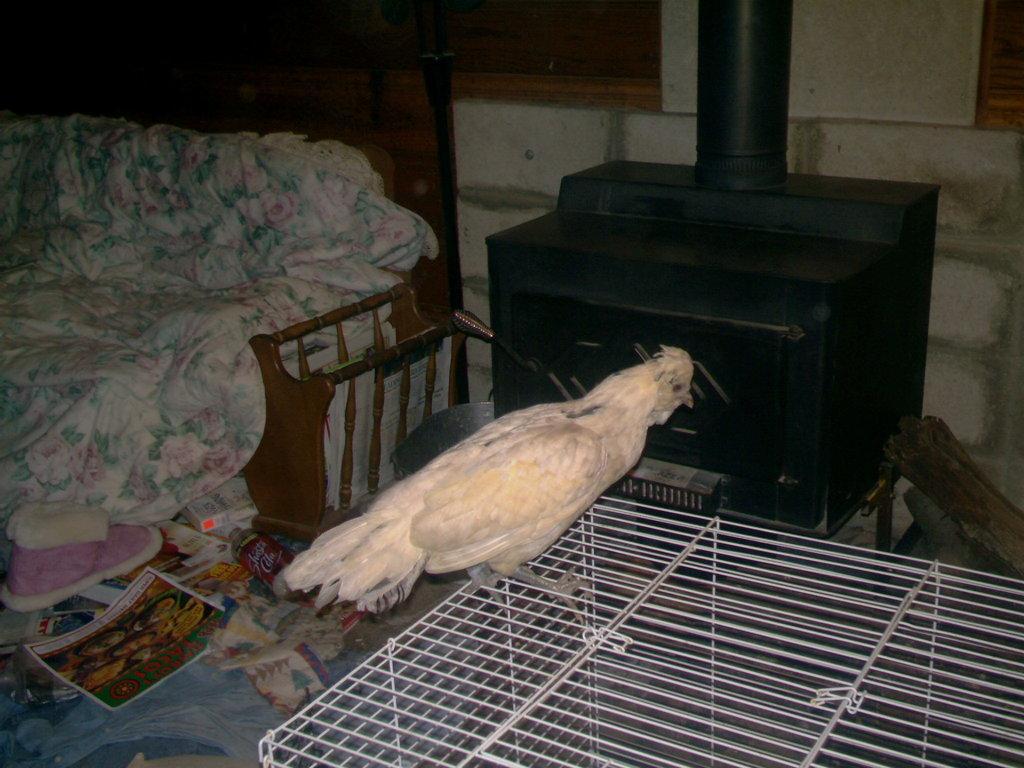Please provide a concise description of this image. This is the picture taken in a room, the bird is standing on a cage. Behind the bird there is a sofa, cloth and a table. 